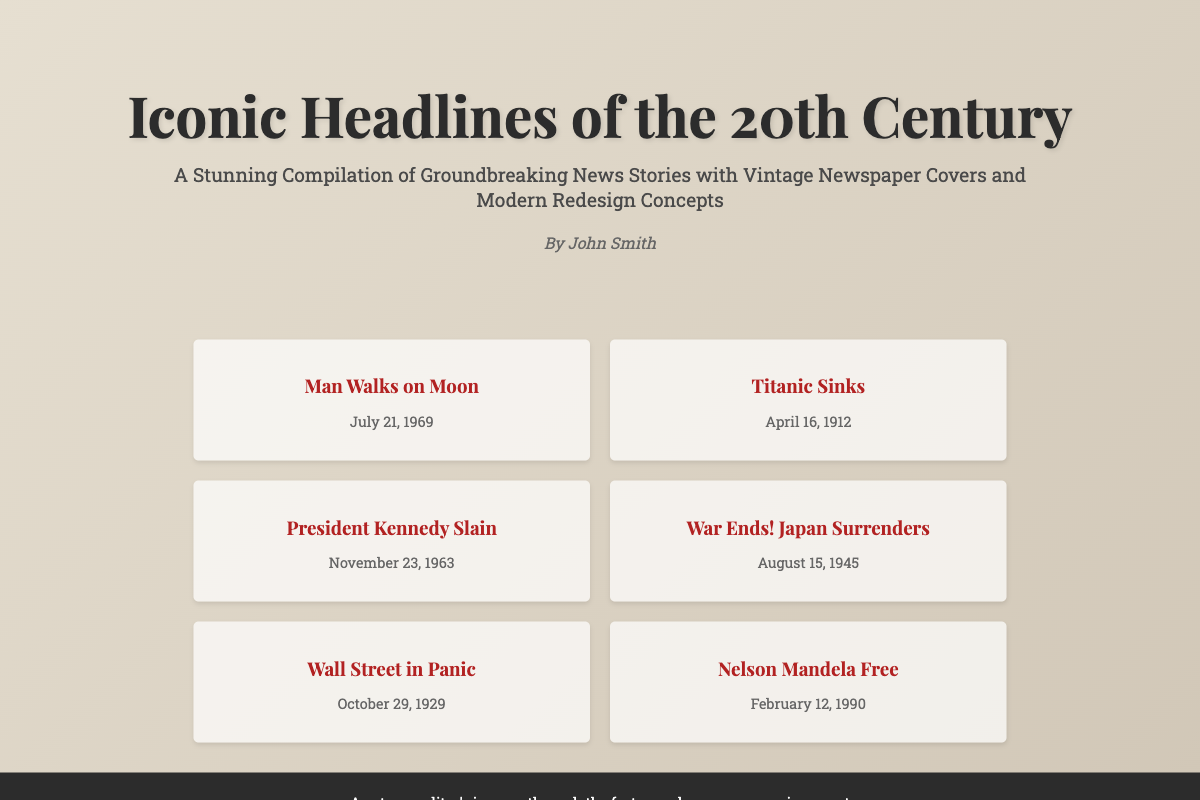What is the title of the book? The title of the book is prominently displayed at the top of the cover.
Answer: Iconic Headlines of the 20th Century Who is the author of the book? The author's name is located below the subtitle on the cover.
Answer: John Smith What significant event happened on July 21, 1969? This is one of the key headlines featured on the cover.
Answer: Man Walks on Moon Which event is associated with April 16, 1912? This date corresponds to a famous news story listed in the headlines section.
Answer: Titanic Sinks How many headlines are listed on the cover? The number of headline entries in the headlines section is counted.
Answer: Six What type of design elements does the book cover use? The design elements include a linear background and a shadow effect.
Answer: Linear gradient and box shadow What is the main theme of the book? The theme is described in the subtitle, summarizing the book's content.
Answer: Groundbreaking News Stories Which headline indicates a significant event in 1945? This headline marks the end of World War II noted on the cover.
Answer: War Ends! Japan Surrenders What font is used for the title? The particular font choice is specified in the CSS for the title.
Answer: Playfair Display What color is the footer text? The footer text's color is defined in the style section of the document.
Answer: White 